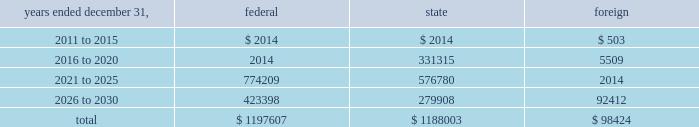American tower corporation and subsidiaries notes to consolidated financial statements the valuation allowance increased from $ 47.8 million as of december 31 , 2009 to $ 48.2 million as of december 31 , 2010 .
The increase was primarily due to valuation allowances on foreign loss carryforwards .
At december 31 , 2010 , the company has provided a valuation allowance of approximately $ 48.2 million which primarily relates to state net operating loss carryforwards , equity investments and foreign items .
The company has not provided a valuation allowance for the remaining deferred tax assets , primarily its federal net operating loss carryforwards , as management believes the company will have sufficient taxable income to realize these federal net operating loss carryforwards during the twenty-year tax carryforward period .
Valuation allowances may be reversed if related deferred tax assets are deemed realizable based on changes in facts and circumstances relevant to the assets 2019 recoverability .
The recoverability of the company 2019s remaining net deferred tax asset has been assessed utilizing projections based on its current operations .
The projections show a significant decrease in depreciation in the later years of the carryforward period as a result of a significant portion of its assets being fully depreciated during the first fifteen years of the carryforward period .
Accordingly , the recoverability of the net deferred tax asset is not dependent on material improvements to operations , material asset sales or other non-routine transactions .
Based on its current outlook of future taxable income during the carryforward period , management believes that the net deferred tax asset will be realized .
The company 2019s deferred tax assets as of december 31 , 2010 and 2009 in the table above do not include $ 122.1 million and $ 113.9 million , respectively , of excess tax benefits from the exercises of employee stock options that are a component of net operating losses .
Total stockholders 2019 equity as of december 31 , 2010 will be increased by $ 122.1 million if and when any such excess tax benefits are ultimately realized .
At december 31 , 2010 , the company had net federal and state operating loss carryforwards available to reduce future federal and state taxable income of approximately $ 1.2 billion , including losses related to employee stock options of $ 0.3 billion .
If not utilized , the company 2019s net operating loss carryforwards expire as follows ( in thousands ) : .
In addition , the company has mexican tax credits of $ 5.2 million which if not utilized would expire in 2017. .
What is the total net operating loss carryforwards? 
Computations: ((1197607 + 1188003) + 98424)
Answer: 2484034.0. 